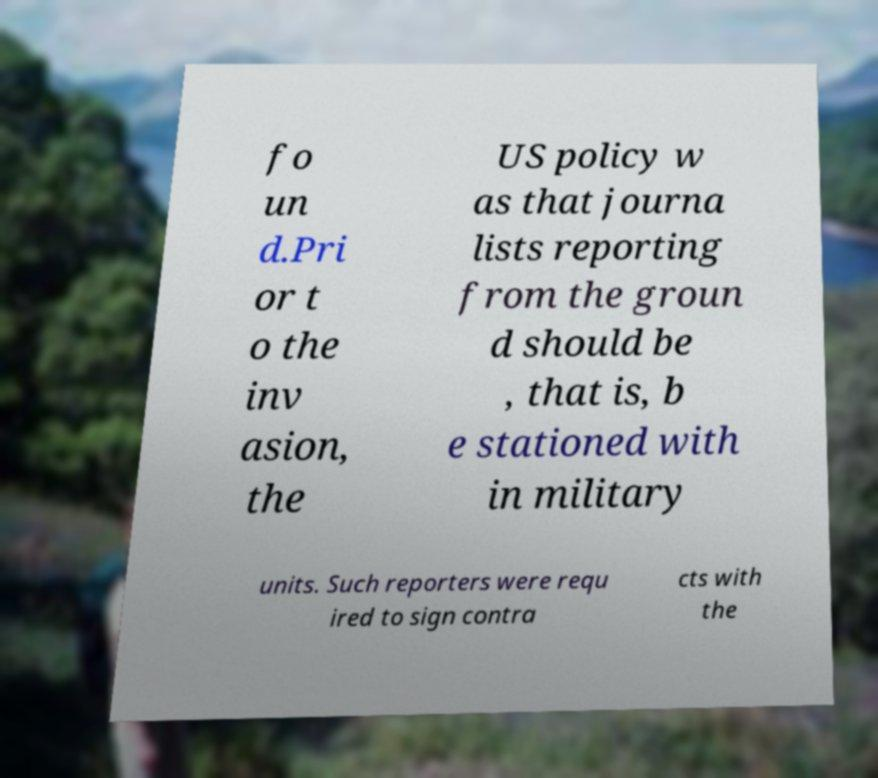I need the written content from this picture converted into text. Can you do that? fo un d.Pri or t o the inv asion, the US policy w as that journa lists reporting from the groun d should be , that is, b e stationed with in military units. Such reporters were requ ired to sign contra cts with the 